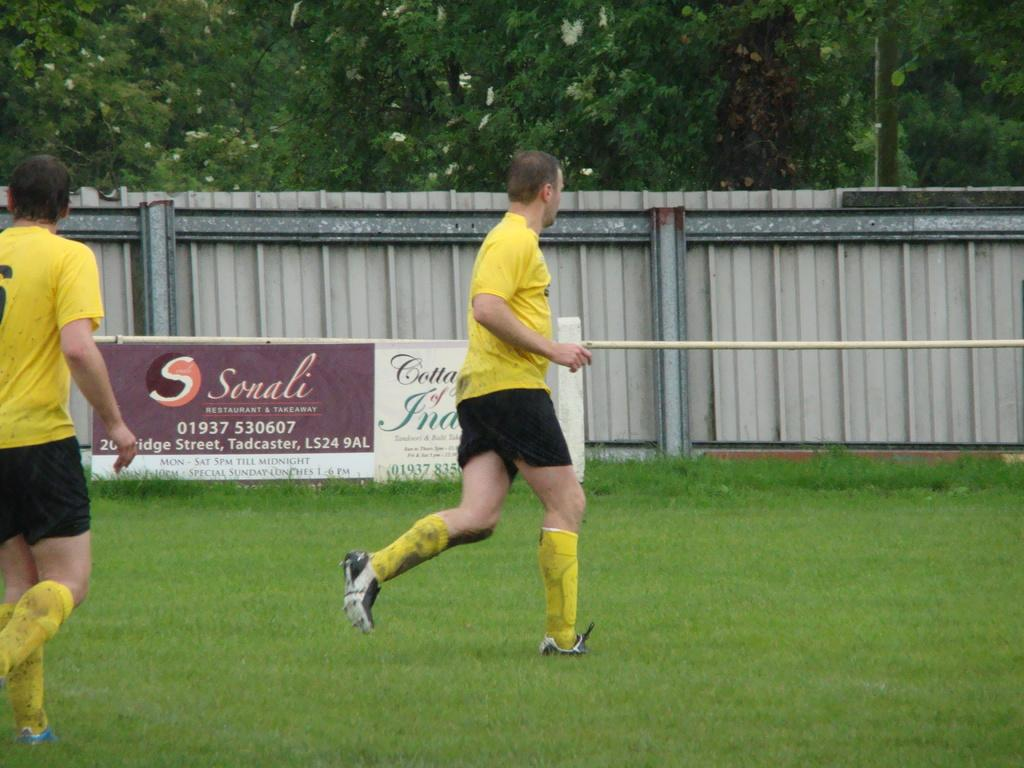How many people are on the ground in the image? There are two persons on the ground in the image. What is the surface they are standing on? The ground is covered in grass. What can be seen in the image besides the persons on the ground? There is a hoarding in the image. What is visible in the background of the image? There is a wall and trees in the background of the image. What type of wound does the mom have in the image? There is no mom or wound present in the image. Can you tell me how many skateboards are visible in the image? There are no skateboards visible in the image. 